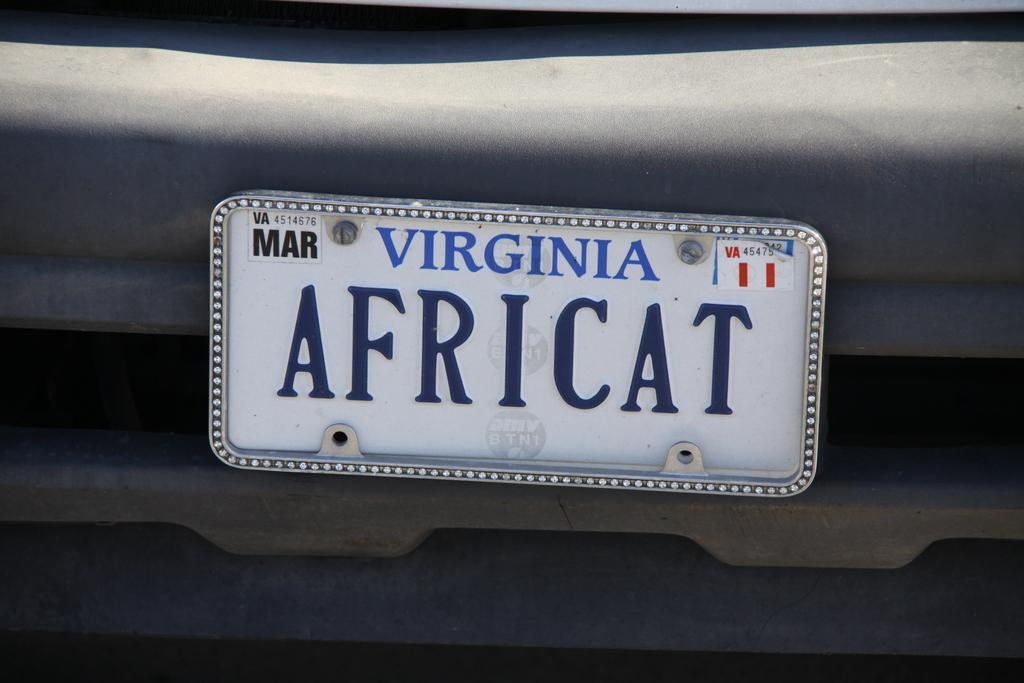What is the main subject in the center of the image? There is a vehicle in the center of the image. What else can be seen in the image besides the vehicle? There is a banner in the image. What does the banner say? The banner has the text "Africat" written on it. How many fowl are present in the image? There are no fowl present in the image. What type of van is being offered in the image? There is no van being offered in the image; it only features a vehicle and a banner with the text "Africat." 